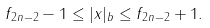Convert formula to latex. <formula><loc_0><loc_0><loc_500><loc_500>f _ { 2 n - 2 } - 1 \leq | x | _ { b } \leq f _ { 2 n - 2 } + 1 .</formula> 